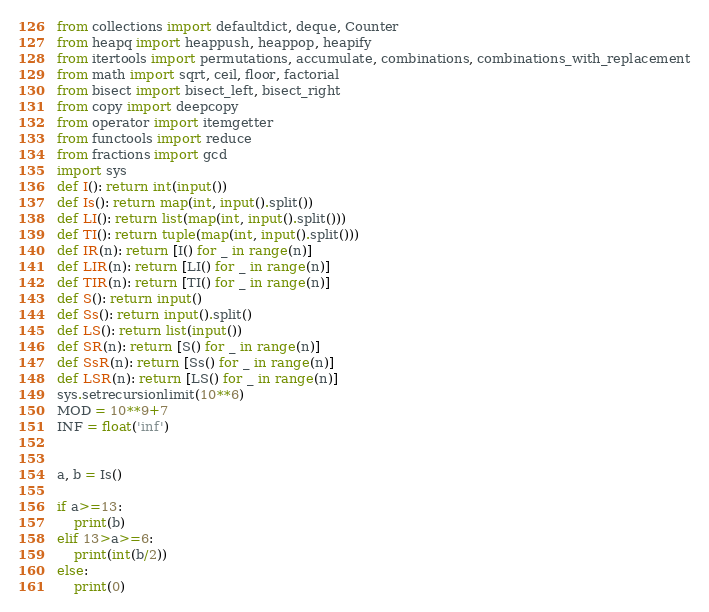Convert code to text. <code><loc_0><loc_0><loc_500><loc_500><_Python_>from collections import defaultdict, deque, Counter
from heapq import heappush, heappop, heapify
from itertools import permutations, accumulate, combinations, combinations_with_replacement
from math import sqrt, ceil, floor, factorial
from bisect import bisect_left, bisect_right
from copy import deepcopy
from operator import itemgetter
from functools import reduce
from fractions import gcd
import sys
def I(): return int(input())
def Is(): return map(int, input().split())
def LI(): return list(map(int, input().split()))
def TI(): return tuple(map(int, input().split()))
def IR(n): return [I() for _ in range(n)]
def LIR(n): return [LI() for _ in range(n)]
def TIR(n): return [TI() for _ in range(n)]
def S(): return input()
def Ss(): return input().split()
def LS(): return list(input())
def SR(n): return [S() for _ in range(n)]
def SsR(n): return [Ss() for _ in range(n)]
def LSR(n): return [LS() for _ in range(n)]
sys.setrecursionlimit(10**6)
MOD = 10**9+7
INF = float('inf')


a, b = Is()

if a>=13:
    print(b)
elif 13>a>=6:
    print(int(b/2))
else:
    print(0)
</code> 